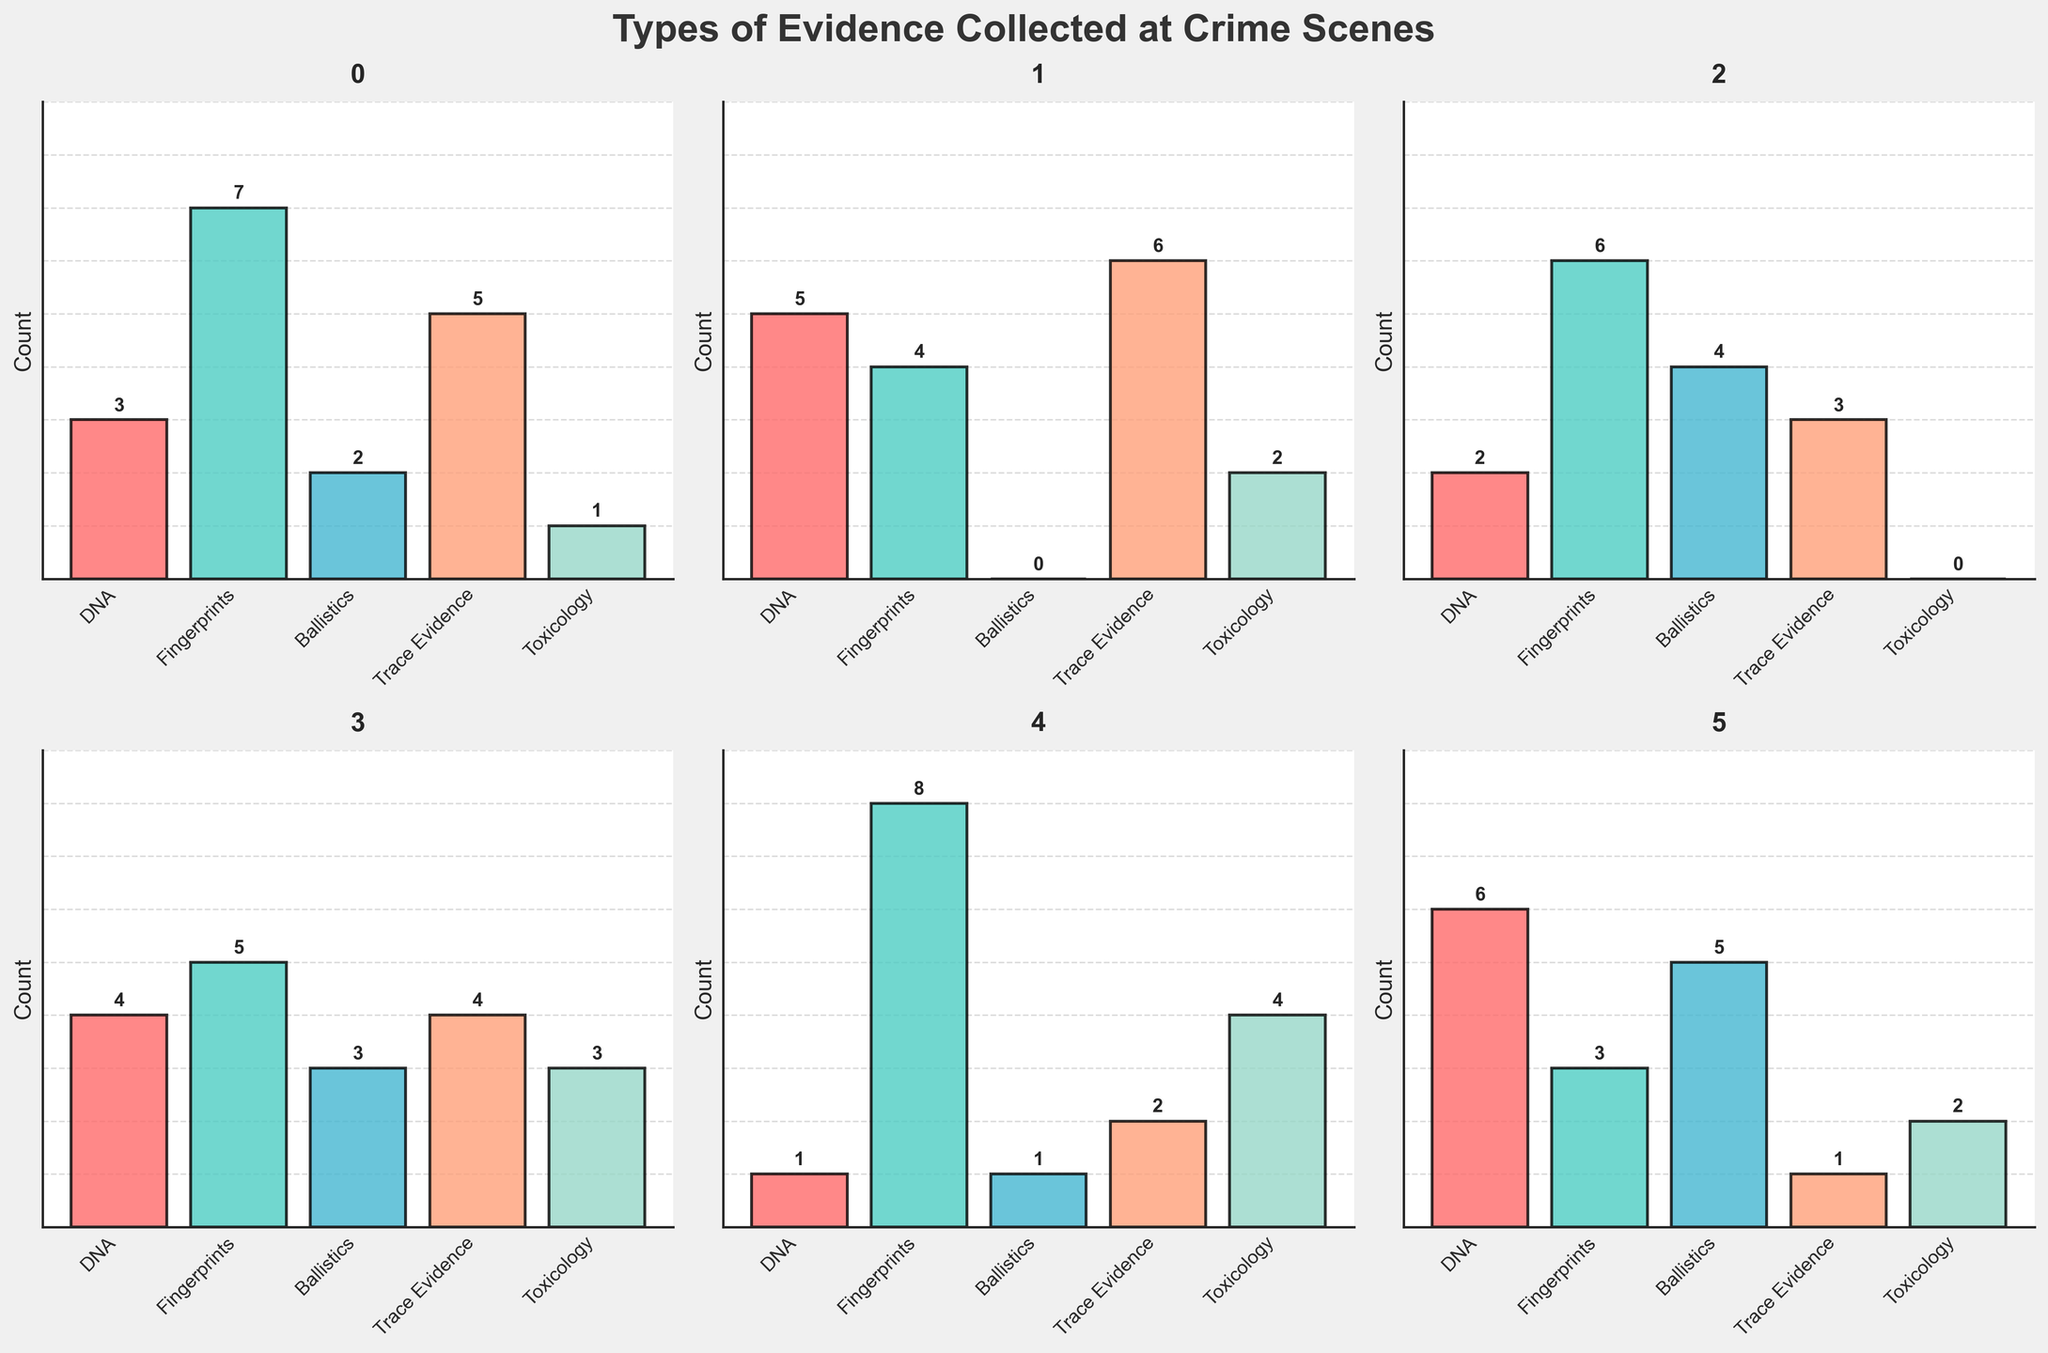What's the highest count of evidence found in Crime Scene 5? Look at the bar chart for Crime Scene 5 and identify the tallest bar, which represents fingerprints with a height of 8.
Answer: 8 Which forensic method has the lowest count in Crime Scene 2? Examine the bar chart for Crime Scene 2 and find the shortest bar, which represents ballistics with a height of 0.
Answer: Ballistics How many types of evidence were collected at Crime Scene 3? Count the number of bars in the bar chart for Crime Scene 3. There are five forensic methods shown, hence five types of evidence.
Answer: 5 What is the total count of DNA evidence collected across all crime scenes? Sum the heights of the DNA bars across all charts: 3+5+2+4+1+6 = 21.
Answer: 21 Which two crime scenes have equal counts for Toxicology evidence collection? Compare the bars for Toxicology across all six crime scenes, and note that Crime Scene 2 and Crime Scene 6 both have a count of 2.
Answer: Crime Scenes 2 and 6 In which crime scene was Ballistics evidence collected the most? Look at all the Ballistics bars, and the tallest bar is in Crime Scene 6 with a height of 5.
Answer: Crime Scene 6 What's the average count of Trace Evidence collected in Crime Scenes 1, 2, and 3? Add the counts for Trace Evidence from Crime Scenes 1, 2, and 3 (5 + 6 + 3 = 14) and divide by the number of scenes (14 / 3 ≈ 4.67).
Answer: 4.67 Does Crime Scene 4 have a higher total count of evidence compared to Crime Scene 5? Add up all the evidence counts for both scenes: Crime Scene 4 total (4+5+3+4+3=19) and Crime Scene 5 total (1+8+1+2+4=16). Compare the sums; 19 is greater than 16.
Answer: Yes Which forensic method has the most variable counts across all six crime scenes? Compare the variability (range between min and max counts) of each forensic method across all charts. Toxicology ranges from 0 to 4, Fingerprints from 3 to 8, DNA from 1 to 6, Ballistics from 0 to 5, and Trace Evidence from 1 to 6.
Answer: Fingerprints What is the count difference of Fingerprints evidence between Crime Scenes 1 and 5? Subtract the Fingerprints count in Crime Scene 1 (7) from that in Crime Scene 5 (8): 8 - 7 = 1.
Answer: 1 